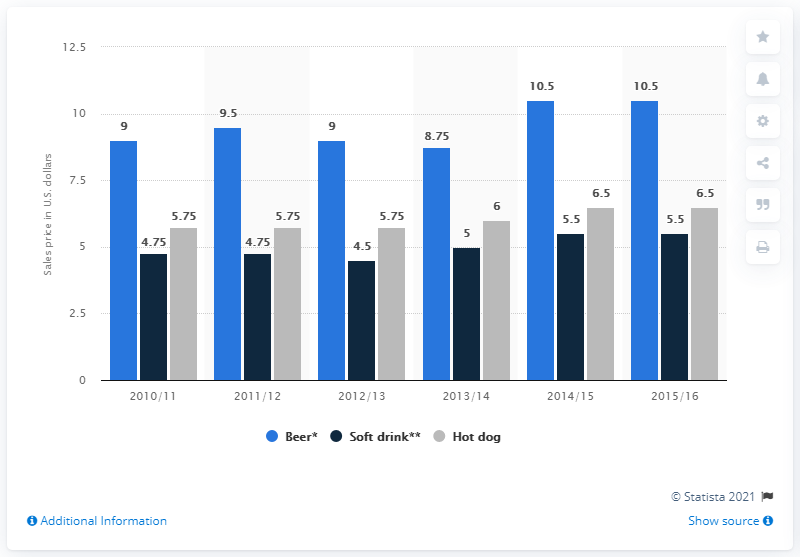Point out several critical features in this image. The average sale price of hot dogs at New York Knicks games between the 2013/14 and 2014/15 seasons was 6.25 dollars. The sale price of beer at New York Knicks games in the 2011/12 season was 9.5 dollars. 